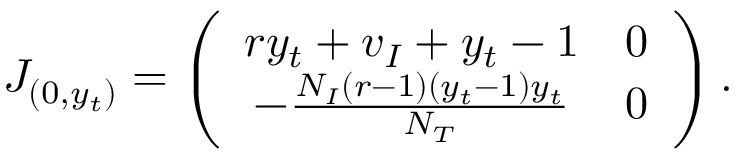Convert formula to latex. <formula><loc_0><loc_0><loc_500><loc_500>J _ { ( 0 , y _ { t } ) } = \left ( \begin{array} { c c } { r y _ { t } + v _ { I } + y _ { t } - 1 } & { 0 } \\ { - \frac { N _ { I } ( r - 1 ) ( y _ { t } - 1 ) y _ { t } } { N _ { T } } } & { 0 } \end{array} \right ) .</formula> 